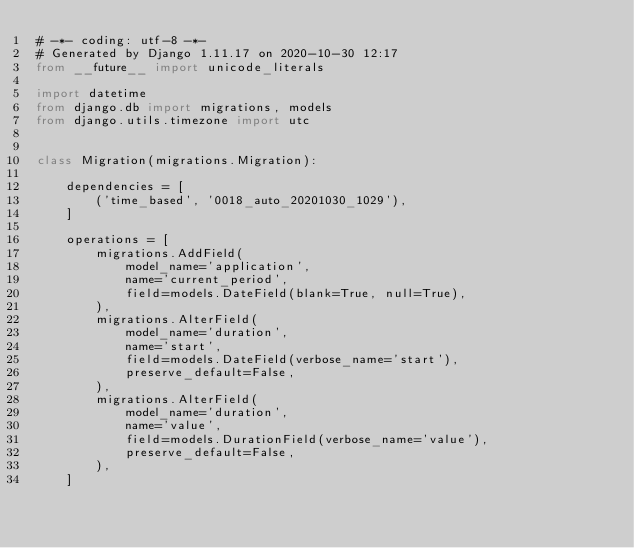<code> <loc_0><loc_0><loc_500><loc_500><_Python_># -*- coding: utf-8 -*-
# Generated by Django 1.11.17 on 2020-10-30 12:17
from __future__ import unicode_literals

import datetime
from django.db import migrations, models
from django.utils.timezone import utc


class Migration(migrations.Migration):

    dependencies = [
        ('time_based', '0018_auto_20201030_1029'),
    ]

    operations = [
        migrations.AddField(
            model_name='application',
            name='current_period',
            field=models.DateField(blank=True, null=True),
        ),
        migrations.AlterField(
            model_name='duration',
            name='start',
            field=models.DateField(verbose_name='start'),
            preserve_default=False,
        ),
        migrations.AlterField(
            model_name='duration',
            name='value',
            field=models.DurationField(verbose_name='value'),
            preserve_default=False,
        ),
    ]
</code> 